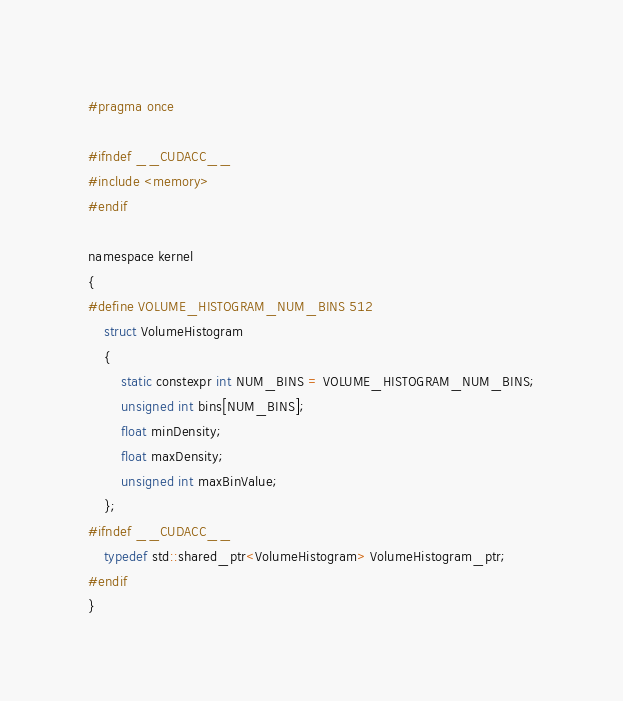<code> <loc_0><loc_0><loc_500><loc_500><_Cuda_>#pragma once

#ifndef __CUDACC__
#include <memory>
#endif

namespace kernel
{
#define VOLUME_HISTOGRAM_NUM_BINS 512
	struct VolumeHistogram
	{
		static constexpr int NUM_BINS = VOLUME_HISTOGRAM_NUM_BINS;
		unsigned int bins[NUM_BINS];
		float minDensity;
		float maxDensity;
		unsigned int maxBinValue;
	};
#ifndef __CUDACC__
	typedef std::shared_ptr<VolumeHistogram> VolumeHistogram_ptr;
#endif
}</code> 